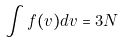<formula> <loc_0><loc_0><loc_500><loc_500>\int f ( v ) d v = 3 N</formula> 